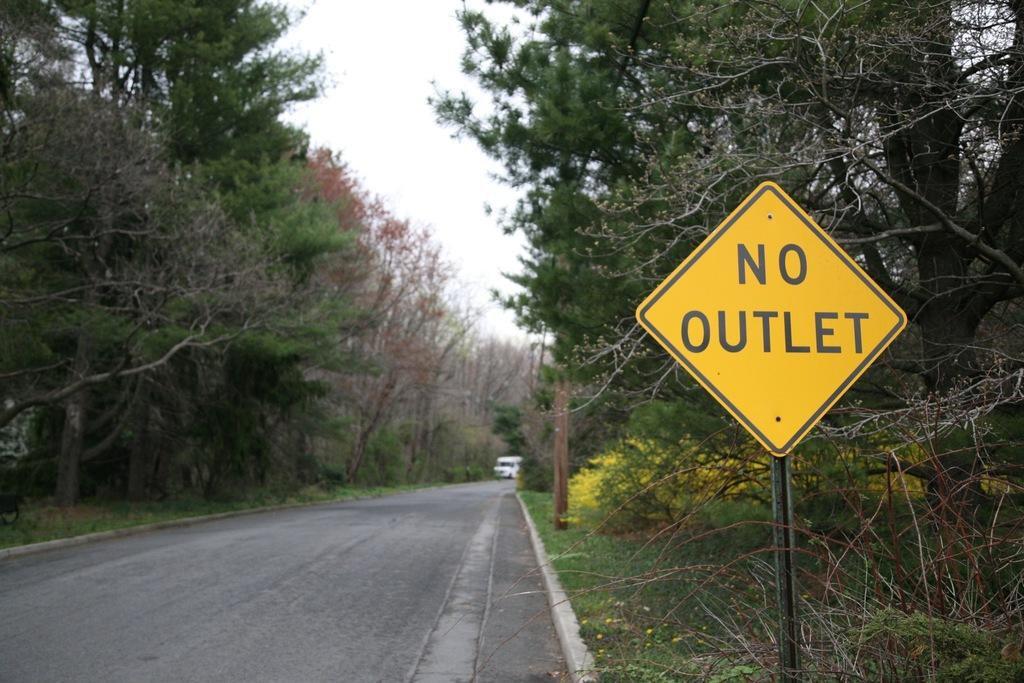<image>
Offer a succinct explanation of the picture presented. A yellow sign by the road says that there is no outlet. 